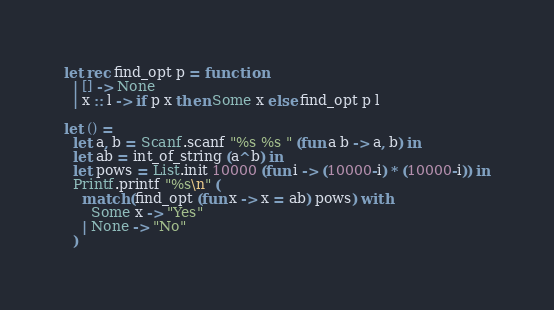Convert code to text. <code><loc_0><loc_0><loc_500><loc_500><_OCaml_>let rec find_opt p = function
  | [] -> None
  | x :: l -> if p x then Some x else find_opt p l

let () =
  let a, b = Scanf.scanf "%s %s " (fun a b -> a, b) in
  let ab = int_of_string (a^b) in
  let pows = List.init 10000 (fun i -> (10000-i) * (10000-i)) in
  Printf.printf "%s\n" (
    match (find_opt (fun x -> x = ab) pows) with
      Some x -> "Yes"
    | None -> "No"
  )
</code> 